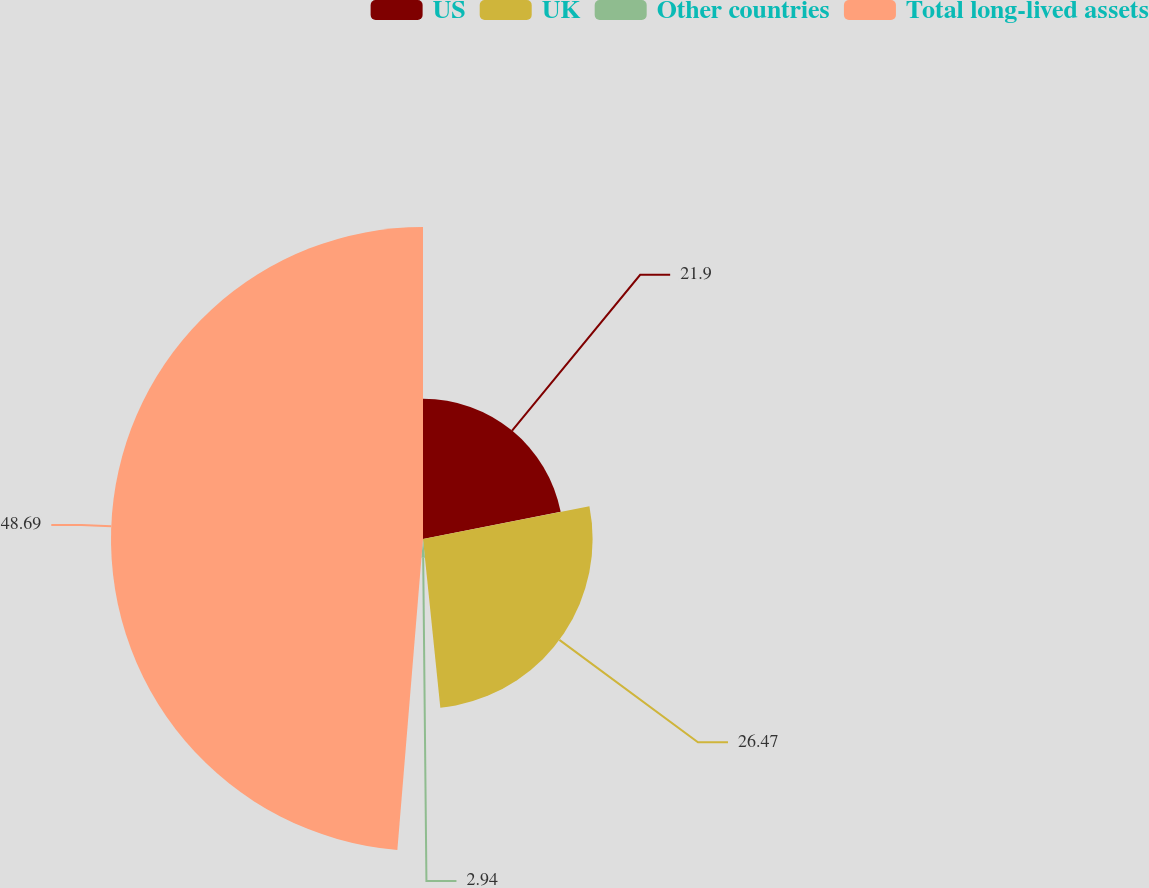<chart> <loc_0><loc_0><loc_500><loc_500><pie_chart><fcel>US<fcel>UK<fcel>Other countries<fcel>Total long-lived assets<nl><fcel>21.9%<fcel>26.47%<fcel>2.94%<fcel>48.69%<nl></chart> 